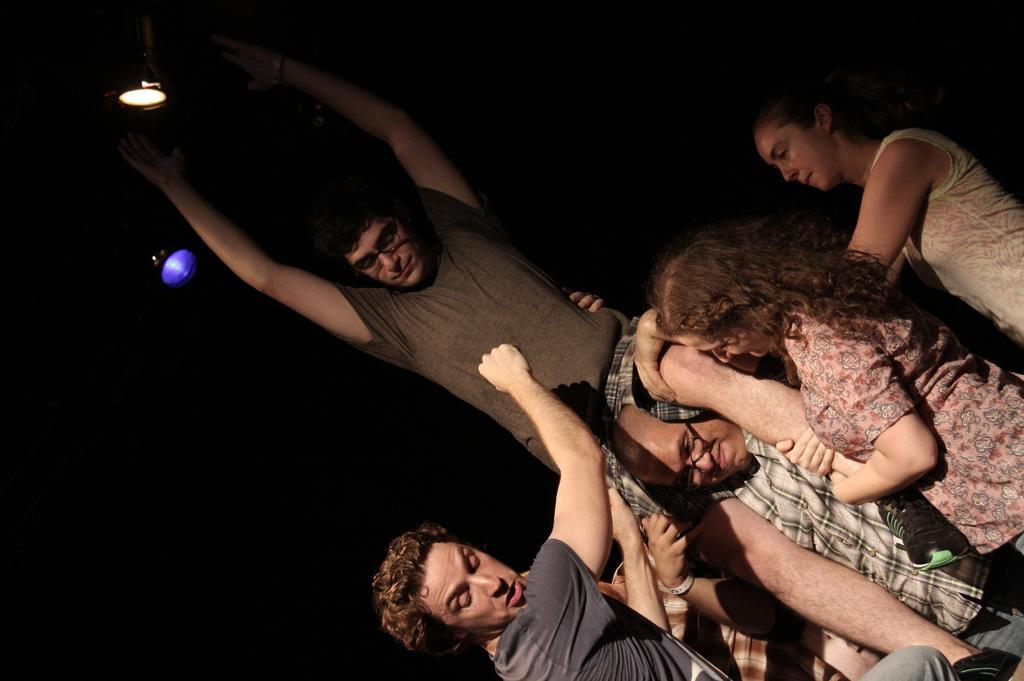What is the main activity happening in the image? There is a person sitting on the shoulders of another person in the image. Are there any other people present in the image? Yes, there are a few other people around them. What can be seen at the top of the image? There are two focus lights at the top of the image. What type of eggs are being used in the apparatus shown in the image? There is no apparatus or eggs present in the image. 